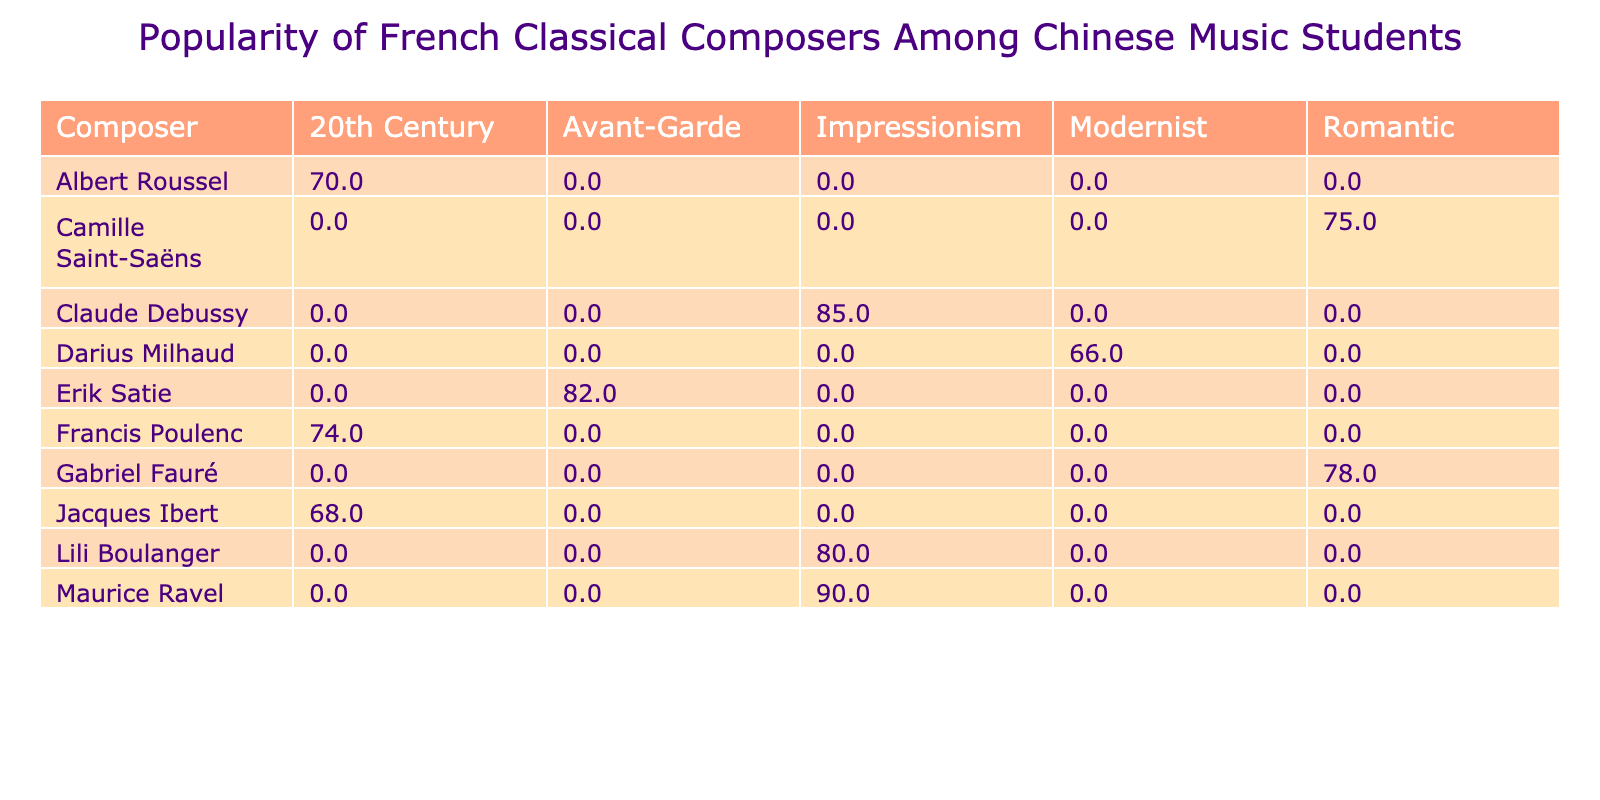What is the highest popularity score among the composers listed? The highest popularity score can be found by examining the table values. The scores for each composer are 85, 78, 90, 75, 82, 68, 74, 80, 70, and 66. The highest score is 90, attributed to Maurice Ravel.
Answer: 90 Which composer has the lowest popularity score in the 20th Century genre? In the 20th Century genre, the popularity scores are 68 for Jacques Ibert, 74 for Francis Poulenc, and 70 for Albert Roussel. The lowest value among these is 68, associated with Jacques Ibert.
Answer: Jacques Ibert What is the average popularity score of the Impressionism composers? The scores for Impressionism are 85 for Claude Debussy, 90 for Maurice Ravel, and 80 for Lili Boulanger. Adding these gives 85 + 90 + 80 = 255. There are three composers, so the average is 255 / 3 = 85.
Answer: 85 Is Erik Satie more popular than Camille Saint-Saëns? Erik Satie has a popularity score of 82, while Camille Saint-Saëns has a score of 75. Since 82 is greater than 75, it shows that Erik Satie is indeed more popular than Camille Saint-Saëns.
Answer: Yes What is the difference in popularity scores between the most popular composer and the least popular composer? The most popular composer is Maurice Ravel with a score of 90, and the least popular is Darius Milhaud with a score of 66. The difference can be calculated as 90 - 66 = 24.
Answer: 24 Which genre has the highest average popularity score based on the composers listed? To find the highest average score by genre, we can calculate the averages: Impressionism: (85 + 90 + 80) / 3 = 85; Romantic: (78 + 75) / 2 = 76.5; Avant-Garde: 82; 20th Century: (68 + 74 + 70) / 3 = 70.67; Modernist: 66. The highest average is thus 85, for Impressionism.
Answer: Impressionism Does any composer from the Modernist genre have a popularity score above 70? The only composer in the Modernist genre is Darius Milhaud with a score of 66. Since 66 is not above 70, the answer is no.
Answer: No Which composer in the Romantic genre is more popular, Gabriel Fauré or Camille Saint-Saëns? The scores for the Romantic genre are Gabriel Fauré with 78 and Camille Saint-Saëns with 75. Comparing these two scores, 78 is greater than 75, making Gabriel Fauré the more popular composer.
Answer: Gabriel Fauré 